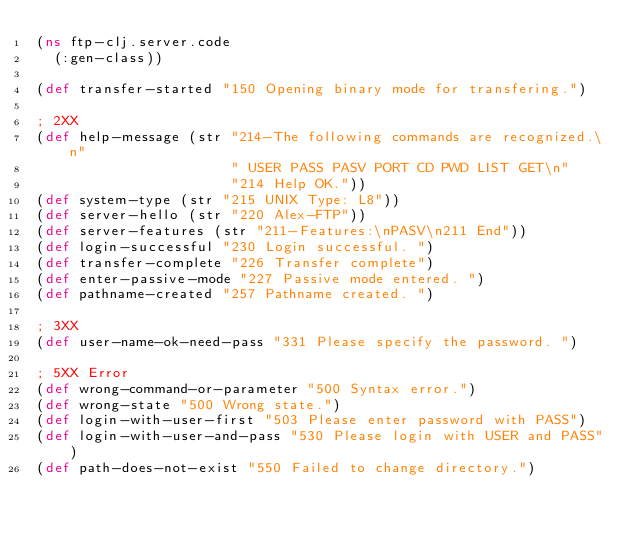<code> <loc_0><loc_0><loc_500><loc_500><_Clojure_>(ns ftp-clj.server.code
  (:gen-class))

(def transfer-started "150 Opening binary mode for transfering.")

; 2XX
(def help-message (str "214-The following commands are recognized.\n"
                       " USER PASS PASV PORT CD PWD LIST GET\n"
                       "214 Help OK."))
(def system-type (str "215 UNIX Type: L8"))
(def server-hello (str "220 Alex-FTP"))
(def server-features (str "211-Features:\nPASV\n211 End"))
(def login-successful "230 Login successful. ")
(def transfer-complete "226 Transfer complete")
(def enter-passive-mode "227 Passive mode entered. ")
(def pathname-created "257 Pathname created. ")

; 3XX
(def user-name-ok-need-pass "331 Please specify the password. ")

; 5XX Error
(def wrong-command-or-parameter "500 Syntax error.")
(def wrong-state "500 Wrong state.")
(def login-with-user-first "503 Please enter password with PASS")
(def login-with-user-and-pass "530 Please login with USER and PASS")
(def path-does-not-exist "550 Failed to change directory.")
</code> 